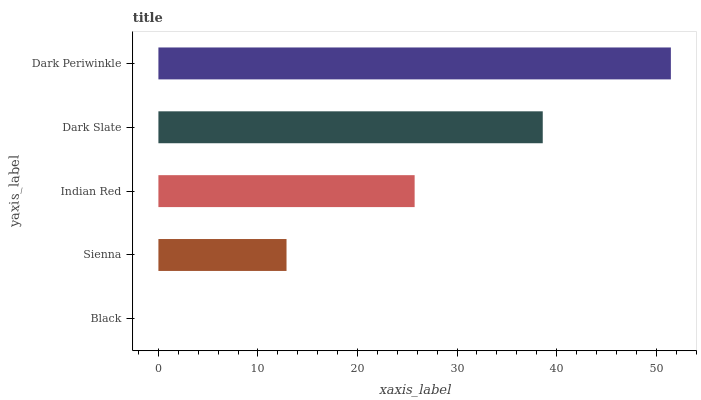Is Black the minimum?
Answer yes or no. Yes. Is Dark Periwinkle the maximum?
Answer yes or no. Yes. Is Sienna the minimum?
Answer yes or no. No. Is Sienna the maximum?
Answer yes or no. No. Is Sienna greater than Black?
Answer yes or no. Yes. Is Black less than Sienna?
Answer yes or no. Yes. Is Black greater than Sienna?
Answer yes or no. No. Is Sienna less than Black?
Answer yes or no. No. Is Indian Red the high median?
Answer yes or no. Yes. Is Indian Red the low median?
Answer yes or no. Yes. Is Sienna the high median?
Answer yes or no. No. Is Dark Periwinkle the low median?
Answer yes or no. No. 